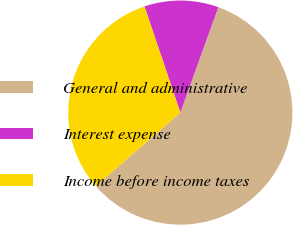Convert chart to OTSL. <chart><loc_0><loc_0><loc_500><loc_500><pie_chart><fcel>General and administrative<fcel>Interest expense<fcel>Income before income taxes<nl><fcel>58.11%<fcel>10.7%<fcel>31.19%<nl></chart> 